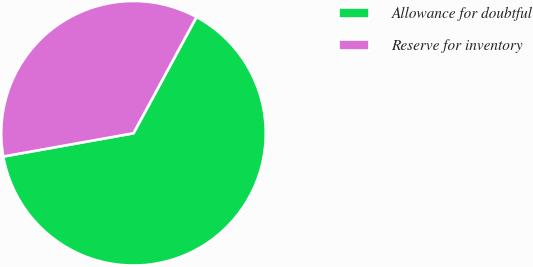Convert chart to OTSL. <chart><loc_0><loc_0><loc_500><loc_500><pie_chart><fcel>Allowance for doubtful<fcel>Reserve for inventory<nl><fcel>64.28%<fcel>35.72%<nl></chart> 